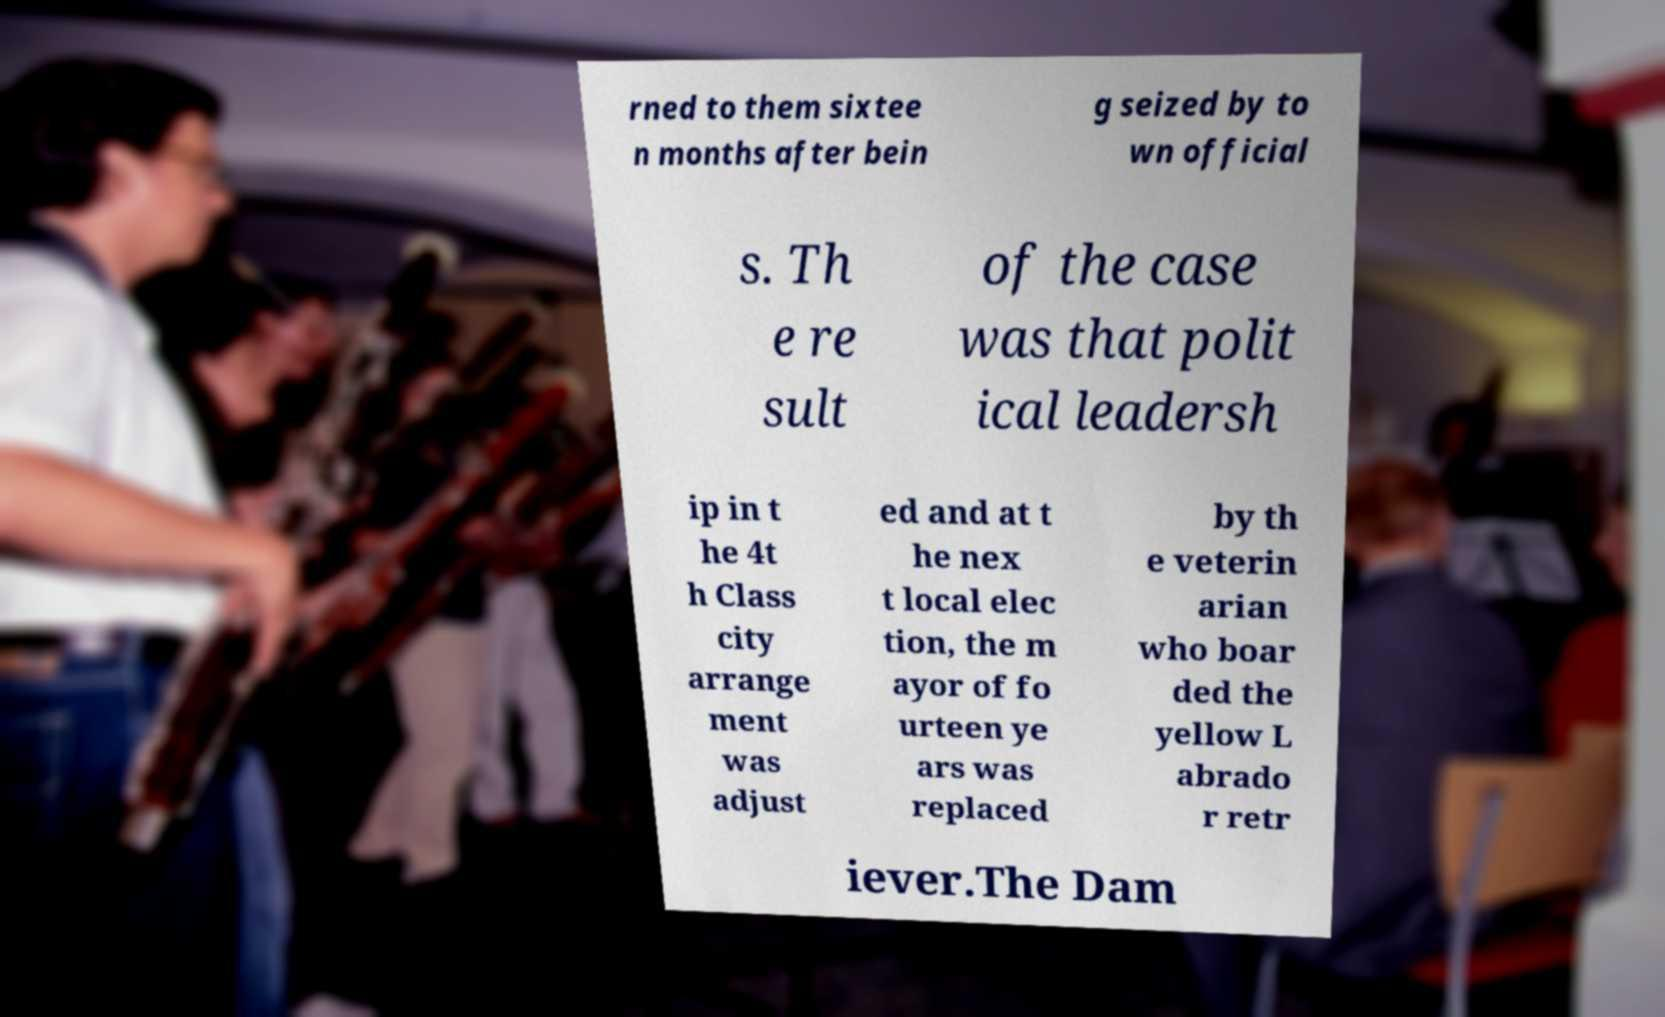Please identify and transcribe the text found in this image. rned to them sixtee n months after bein g seized by to wn official s. Th e re sult of the case was that polit ical leadersh ip in t he 4t h Class city arrange ment was adjust ed and at t he nex t local elec tion, the m ayor of fo urteen ye ars was replaced by th e veterin arian who boar ded the yellow L abrado r retr iever.The Dam 